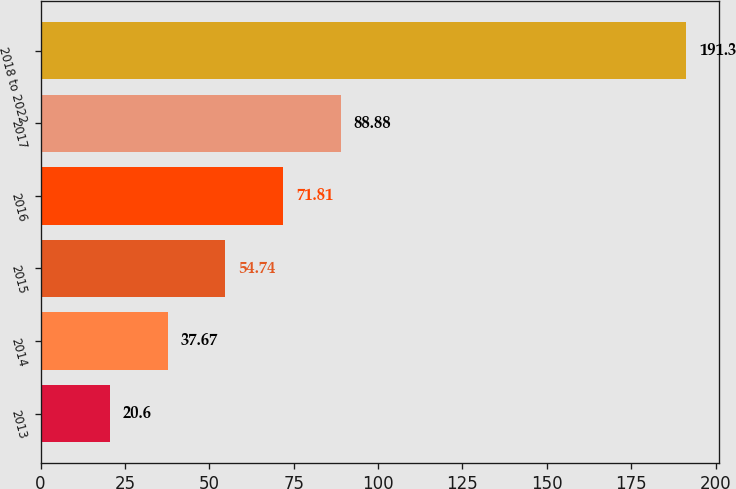Convert chart. <chart><loc_0><loc_0><loc_500><loc_500><bar_chart><fcel>2013<fcel>2014<fcel>2015<fcel>2016<fcel>2017<fcel>2018 to 2022<nl><fcel>20.6<fcel>37.67<fcel>54.74<fcel>71.81<fcel>88.88<fcel>191.3<nl></chart> 